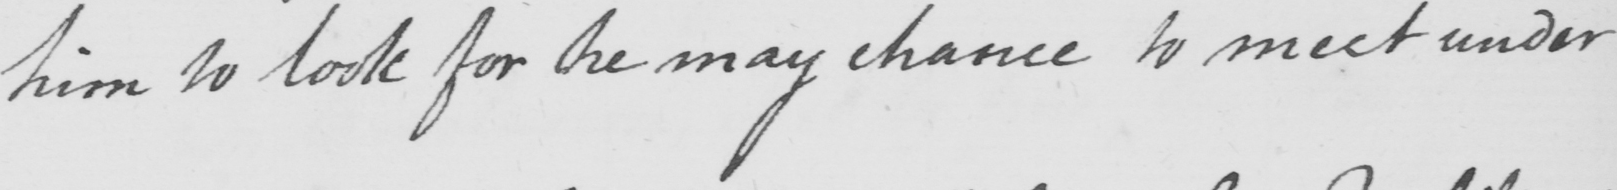Transcribe the text shown in this historical manuscript line. him to look for he may chance to meet under 